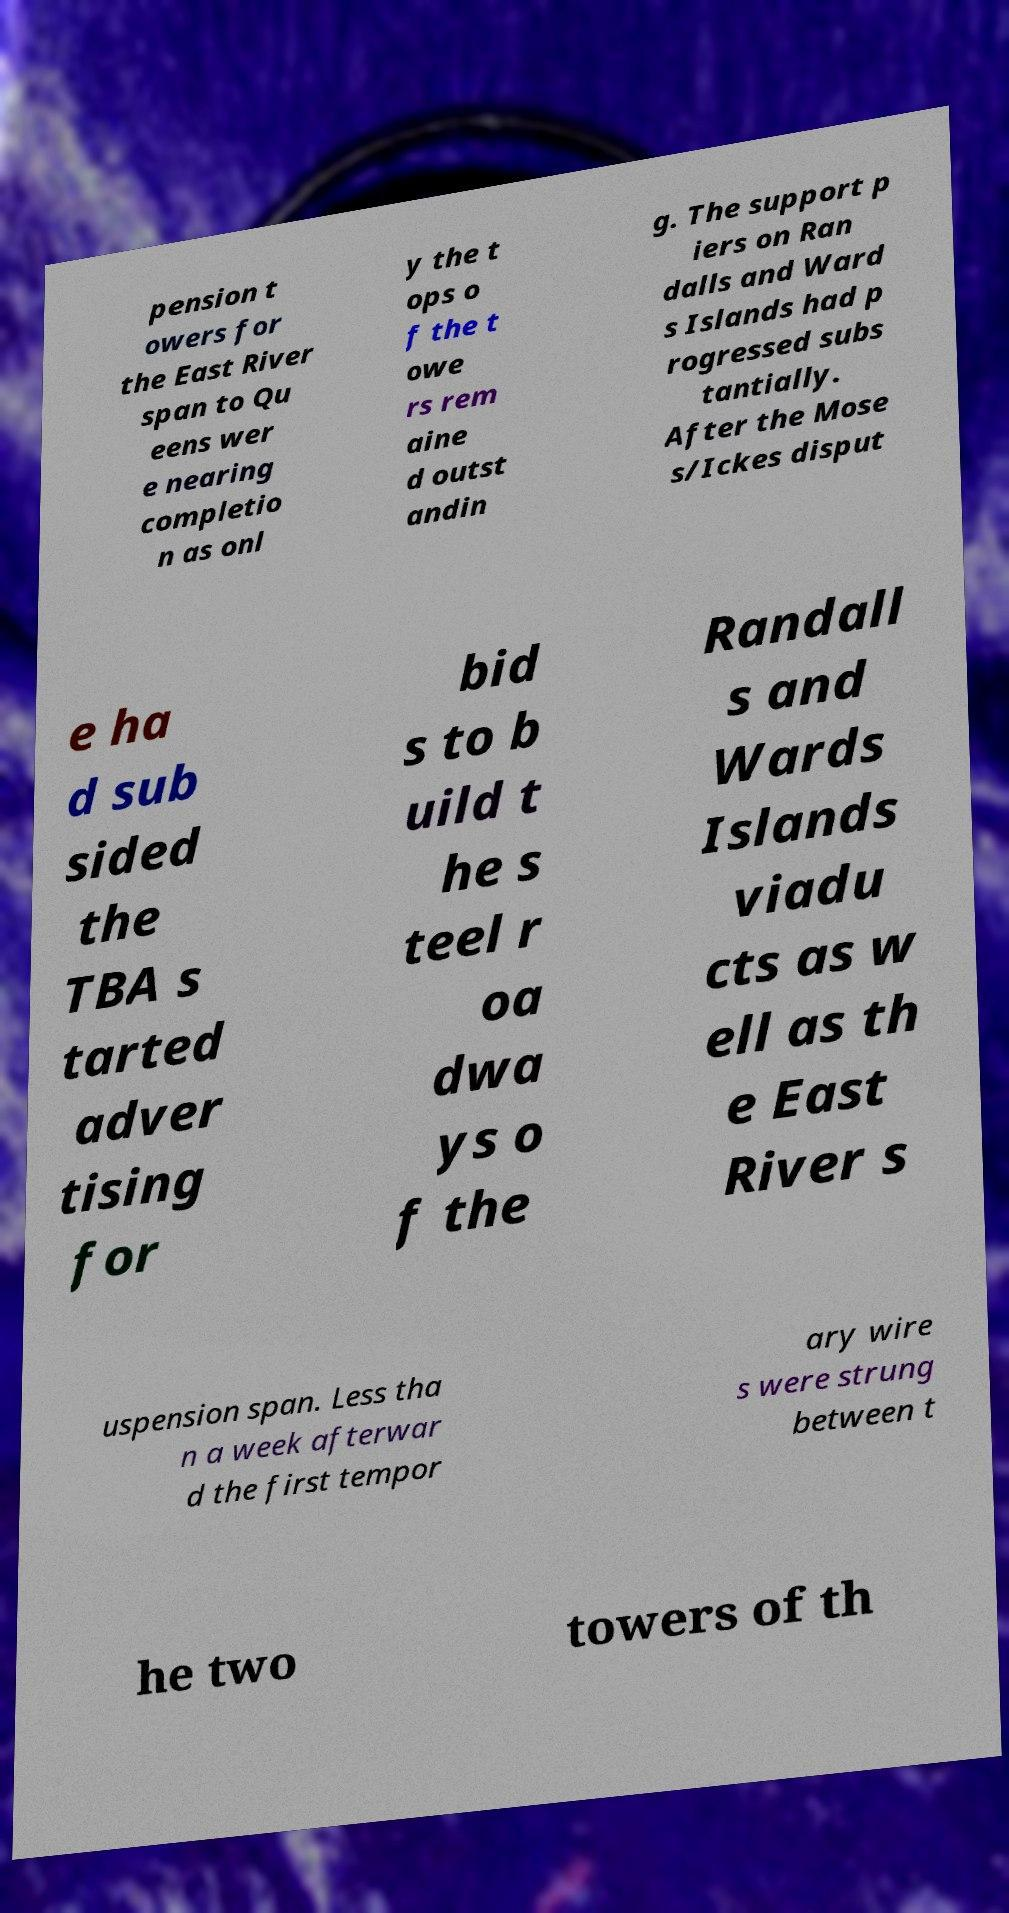Please identify and transcribe the text found in this image. pension t owers for the East River span to Qu eens wer e nearing completio n as onl y the t ops o f the t owe rs rem aine d outst andin g. The support p iers on Ran dalls and Ward s Islands had p rogressed subs tantially. After the Mose s/Ickes disput e ha d sub sided the TBA s tarted adver tising for bid s to b uild t he s teel r oa dwa ys o f the Randall s and Wards Islands viadu cts as w ell as th e East River s uspension span. Less tha n a week afterwar d the first tempor ary wire s were strung between t he two towers of th 